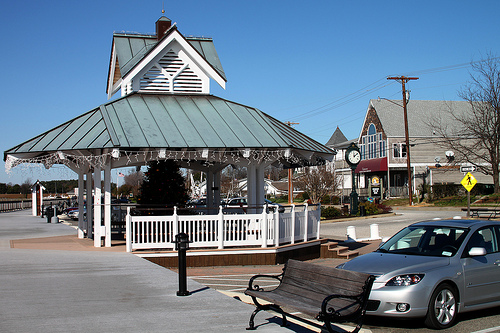Please provide a short description for this region: [0.61, 0.61, 0.88, 0.8]. The region identified by coordinates [0.61, 0.61, 0.88, 0.8] shows a metallic silver car. 